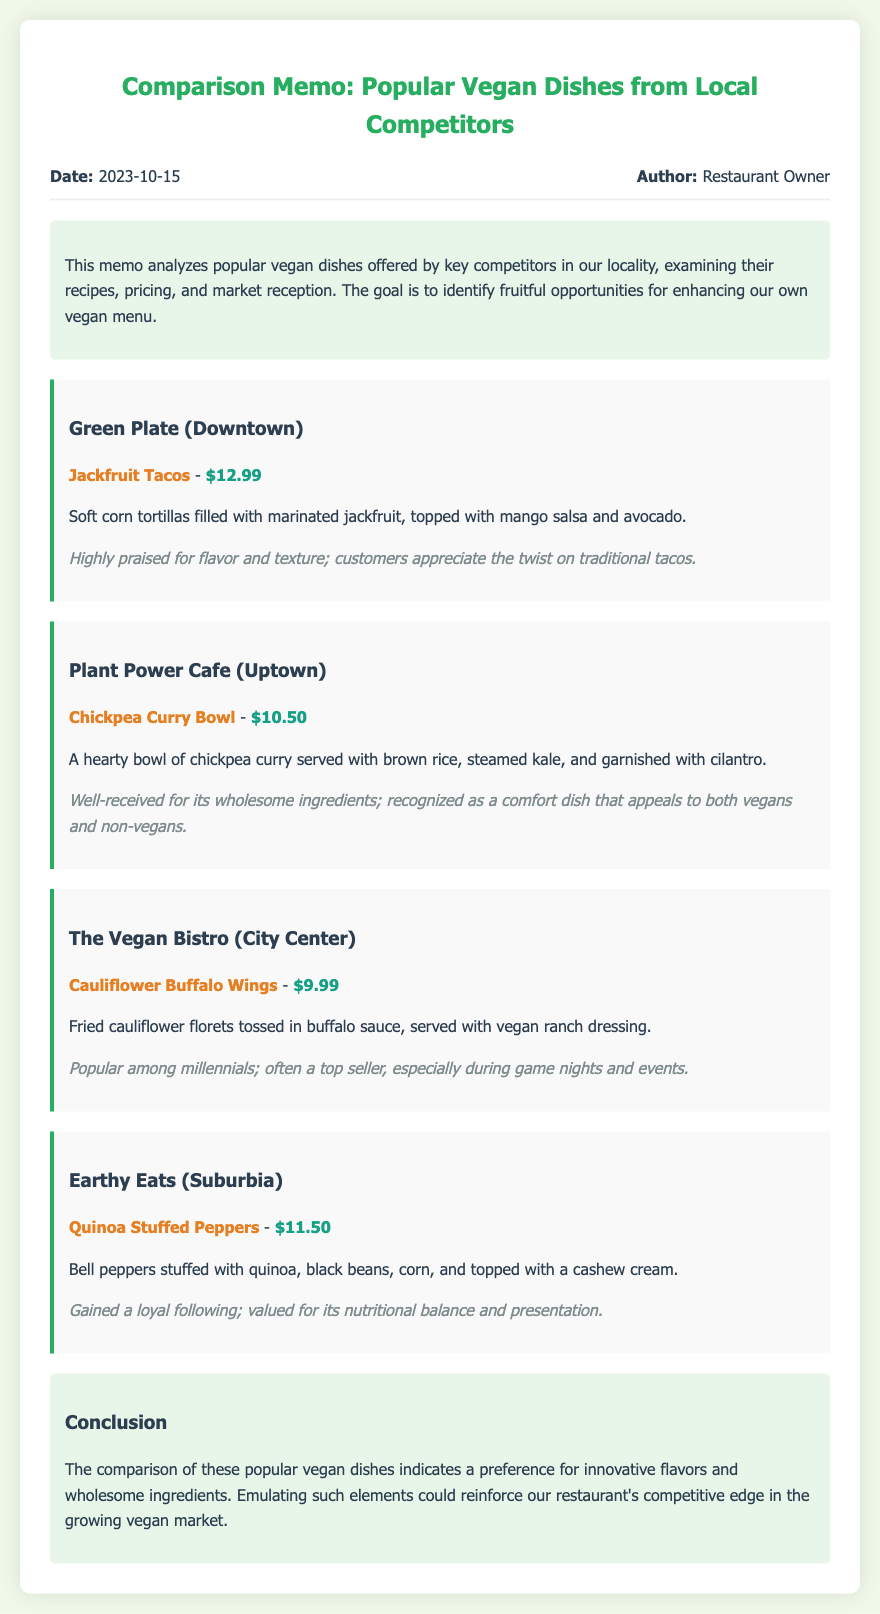What is the date of the memo? The date of the memo is mentioned in the memo header section.
Answer: 2023-10-15 What dish is offered by Green Plate? The dish offered by Green Plate is listed in the competitor section of the document.
Answer: Jackfruit Tacos What is the price of the Chickpea Curry Bowl? The price is specified alongside the dish name in the competitor section.
Answer: $10.50 Which dish is popular among millennials? This information is provided in the reception section for The Vegan Bistro.
Answer: Cauliflower Buffalo Wings What type of ingredient does the Quinoa Stuffed Peppers contain? The ingredients are detailed in the description of the dish in the document.
Answer: Quinoa Which competitor's dish gained a loyal following? This is mentioned in the reception section of the Earthy Eats entry.
Answer: Earthy Eats What is the common market preference indicated in the conclusion? The conclusion summarizes the analysis, highlighting what customers prefer.
Answer: Innovative flavors and wholesome ingredients What dish is appreciated as a comfort dish? This is mentioned in the reception section of the Plant Power Cafe.
Answer: Chickpea Curry Bowl 